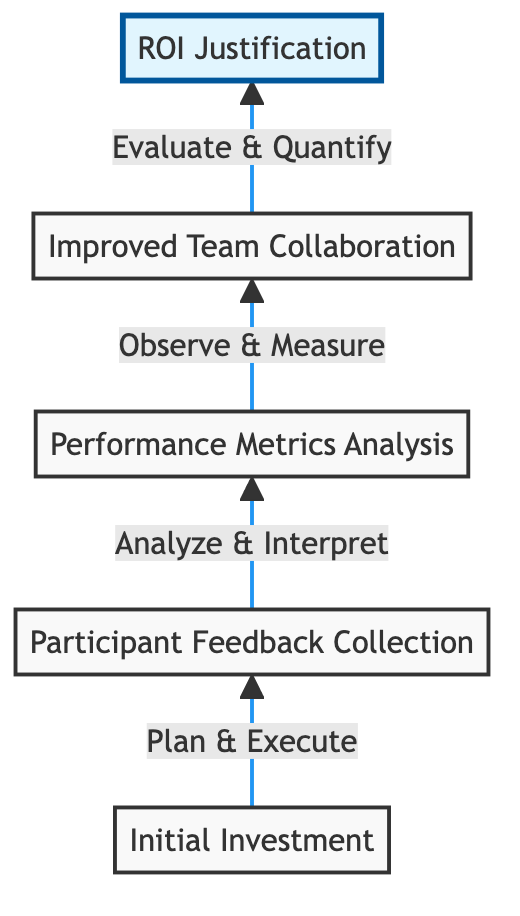What does the arrow between Initial Investment and Participant Feedback Collection signify? The arrow indicates a direct relationship, where Participant Feedback Collection is the subsequent step that follows after Initial Investment is made.
Answer: Plan & Execute What is the last node in the flow chart? The last node, found at the top of the diagram, is "ROI Justification," representing the final assessment of the initiatives taken.
Answer: ROI Justification Which node focuses on analyzing key performance indicators? The node that focuses on this analysis is "Performance Metrics Analysis," where key performance indicators such as employee engagement scores are evaluated.
Answer: Performance Metrics Analysis What is the relationship between Improved Team Collaboration and ROI Justification? Improved Team Collaboration leads to ROI Justification by evaluating and quantifying the observed benefits from enhanced teamwork.
Answer: Evaluate & Quantify How does Participant Feedback Collection influence the next step? Participant Feedback Collection influences the next step, Performance Metrics Analysis, by providing the data needed to analyze employee satisfaction levels and experiences.
Answer: Analyze & Interpret What action is associated with Improved Team Collaboration? The associated action is "Observe & Measure," which indicates the evaluation of teamwork and communication improvements.
Answer: Observe & Measure Which two nodes are directly connected to Performance Metrics Analysis? The nodes directly connected to Performance Metrics Analysis are Participant Feedback Collection and Improved Team Collaboration, reflecting the flow of insights from feedback to collaboration metrics.
Answer: Participant Feedback Collection and Improved Team Collaboration 